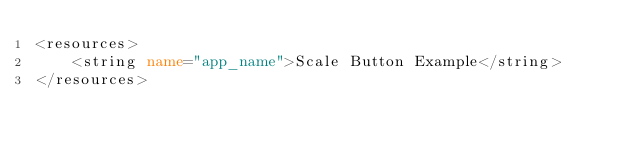Convert code to text. <code><loc_0><loc_0><loc_500><loc_500><_XML_><resources>
    <string name="app_name">Scale Button Example</string>
</resources>
</code> 